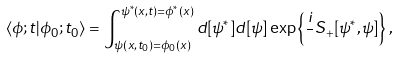<formula> <loc_0><loc_0><loc_500><loc_500>\langle \phi ; t | \phi _ { 0 } ; t _ { 0 } \rangle = \int _ { \psi ( { x } , t _ { 0 } ) = \phi _ { 0 } ( { x } ) } ^ { \psi ^ { * } ( { x } , t ) = \phi ^ { * } ( { x } ) } d [ \psi ^ { * } ] d [ \psi ] \exp \left \{ \frac { i } { } S _ { + } [ \psi ^ { * } , \psi ] \right \} ,</formula> 